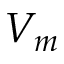Convert formula to latex. <formula><loc_0><loc_0><loc_500><loc_500>V _ { m }</formula> 